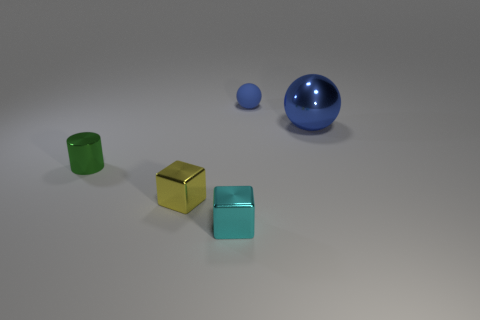There is a small metal thing that is left of the small yellow metallic object; does it have the same shape as the yellow thing?
Offer a very short reply. No. How many things are either red matte things or shiny cubes that are behind the cyan cube?
Make the answer very short. 1. Is the material of the small cylinder that is behind the tiny yellow shiny block the same as the big object?
Offer a terse response. Yes. Is there anything else that has the same size as the matte sphere?
Ensure brevity in your answer.  Yes. What material is the cube that is behind the shiny block that is on the right side of the yellow cube made of?
Your answer should be compact. Metal. Is the number of metal things that are behind the metal cylinder greater than the number of small yellow metallic objects that are behind the big blue ball?
Give a very brief answer. Yes. How big is the cyan thing?
Make the answer very short. Small. There is a object behind the large blue shiny ball; does it have the same color as the big thing?
Your answer should be very brief. Yes. Is there anything else that is the same shape as the small green metal thing?
Give a very brief answer. No. There is a rubber thing behind the small cyan block; are there any tiny cyan shiny blocks that are right of it?
Give a very brief answer. No. 